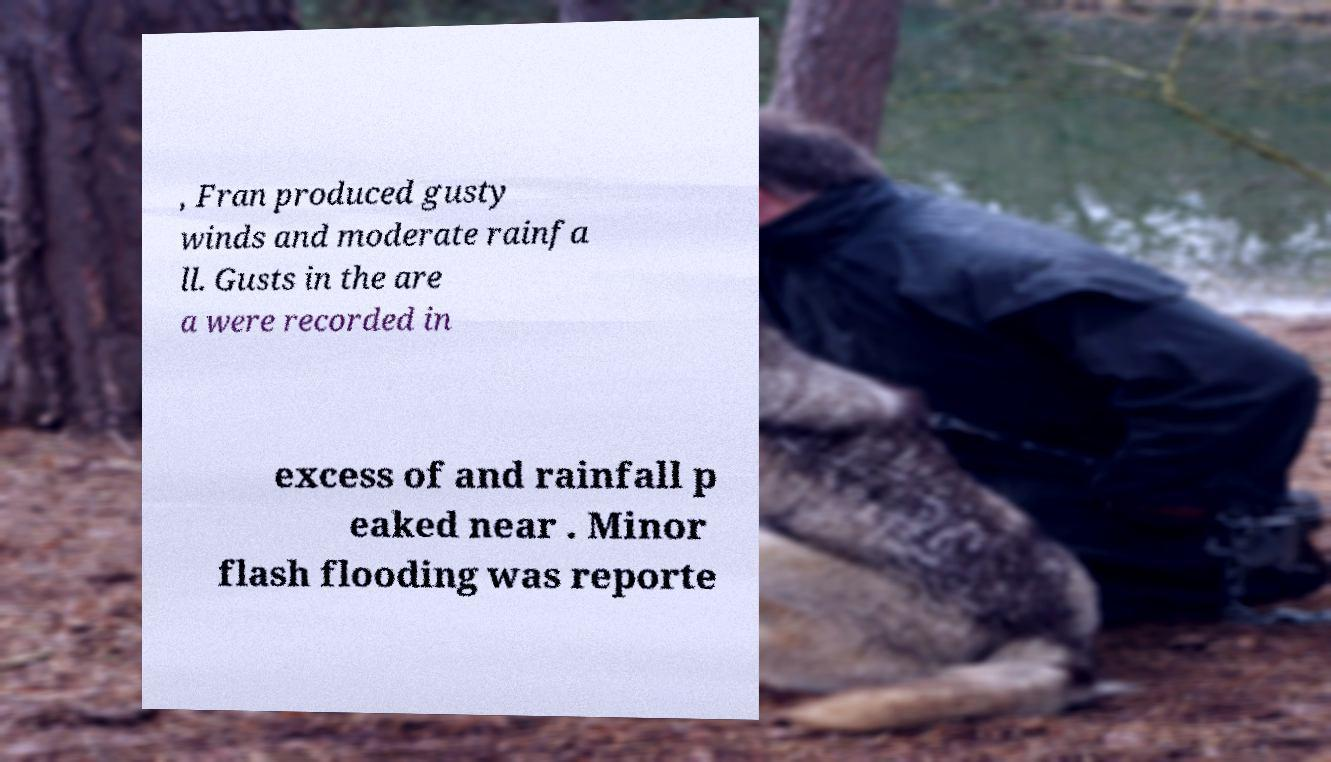Could you extract and type out the text from this image? , Fran produced gusty winds and moderate rainfa ll. Gusts in the are a were recorded in excess of and rainfall p eaked near . Minor flash flooding was reporte 